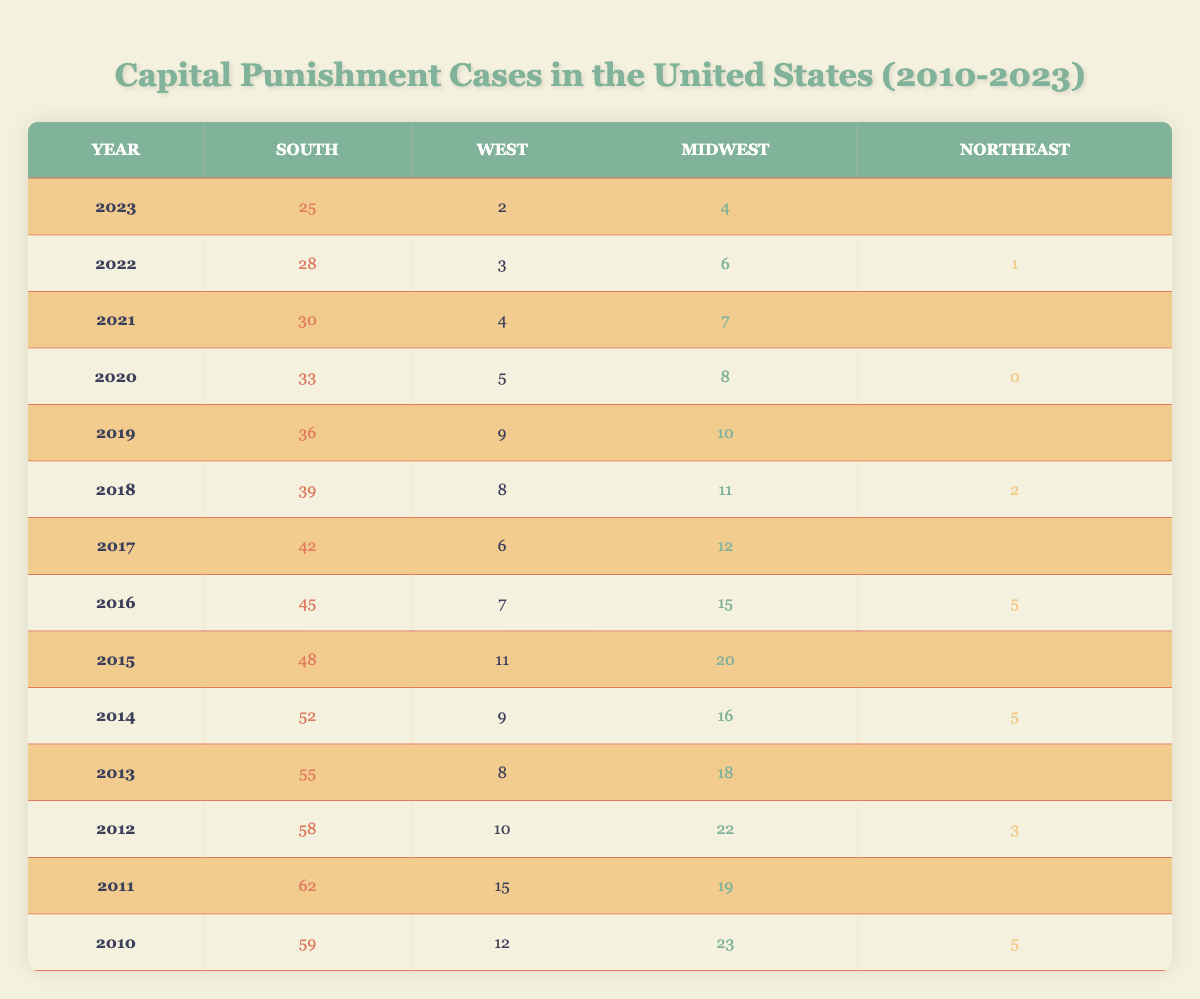What was the total number of capital punishment cases in the South in 2010? The table shows that the number of cases in the South for the year 2010 is 59.
Answer: 59 In which region were the most capital punishment cases recorded in 2011? The table indicates that in 2011, the South had 62 cases, which is the highest among the regions listed.
Answer: South What is the trend in capital punishment cases in the West from 2010 to 2023? The cases in the West for the years are: 12 (2010), 15 (2011), 10 (2012), 8 (2013), 9 (2014), 11 (2015), 7 (2016), 6 (2017), 8 (2018), 9 (2019), 5 (2020), 4 (2021), 3 (2022), 2 (2023). This shows a general downward trend over the years.
Answer: Decreasing How many total capital punishment cases were recorded in the Northeast from 2010 to 2023? The total cases in the Northeast are: 5 (2010), 4 (2011), 3 (2012), 6 (2013), 5 (2014), 4 (2015), 5 (2016), 3 (2017), 2 (2018), 1 (2019), 0 (2020), 2 (2021), 1 (2022), 0 (2023), which sums to 36 cases.
Answer: 36 What was the average number of capital punishment cases in the Midwest from 2010 to 2023? The cases in the Midwest are: 23 (2010), 19 (2011), 22 (2012), 18 (2013), 16 (2014), 20 (2015), 15 (2016), 12 (2017), 11 (2018), 10 (2019), 8 (2020), 7 (2021), 6 (2022), 4 (2023). The total is  226 over 14 years, so the average is 226/14 which equals approximately 16.14.
Answer: 16.14 Did the South ever record less than 40 capital punishment cases in a given year from 2010 to 2023? For all years from 2010 to 2023, the South's lowest recorded cases were 25 in 2023, which is less than 40.
Answer: Yes Which region had the least number of capital punishment cases in 2020? The table shows that the Northeast had 0 cases in 2020, making it the region with the least number of cases that year.
Answer: Northeast What was the decrease in capital punishment cases in the South from 2015 to 2023? The South recorded 48 cases in 2015 and 25 cases in 2023. The decrease is 48 - 25 = 23 cases.
Answer: 23 Which region saw the most consistent number of capital punishment cases from 2010 to 2023? By examining the table, the Midwest shows less variation in numbers compared to the South and West, ranging between 4 and 23 cases, indicating more consistency.
Answer: Midwest What was the highest number of capital punishment cases in a single year among all regions from 2010 to 2023? The highest value recorded was 62 cases in the South in 2011, which is the maximum among all regions and years listed.
Answer: 62 In which year did the South experience the largest drop in capital punishment cases compared to the previous year? The South's highest number was 62 in 2011, dropping to 58 in 2012, a decrease of 4 cases. However, the biggest drop of 7 cases occurred from 2016 (45) to 2017 (42).
Answer: 2016 to 2017 